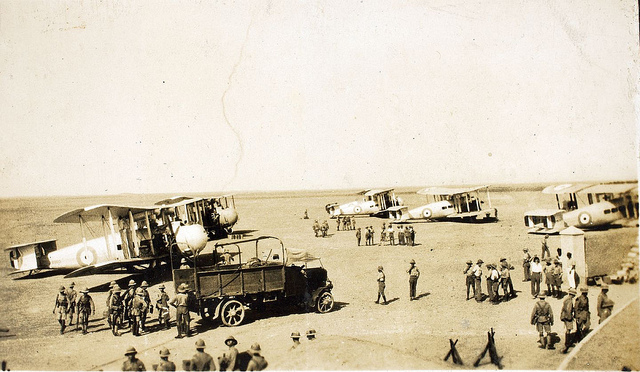<image>What year is this? It is unknown what year this is, as there are multiple answers such as 1898, 1903, 1940, etc. What year is this? I don't know what year this is. It can be any year between 1898 and 1940. 